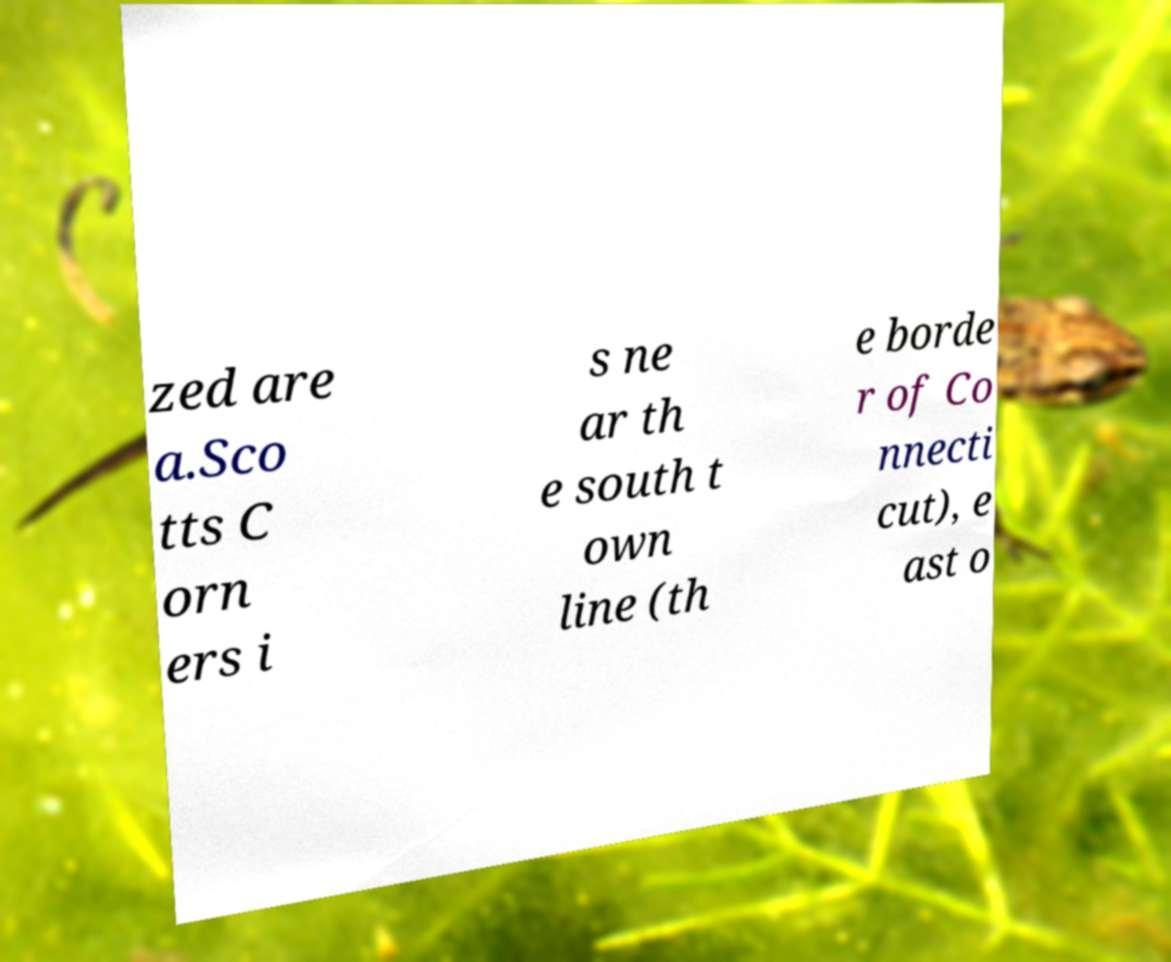Could you extract and type out the text from this image? zed are a.Sco tts C orn ers i s ne ar th e south t own line (th e borde r of Co nnecti cut), e ast o 